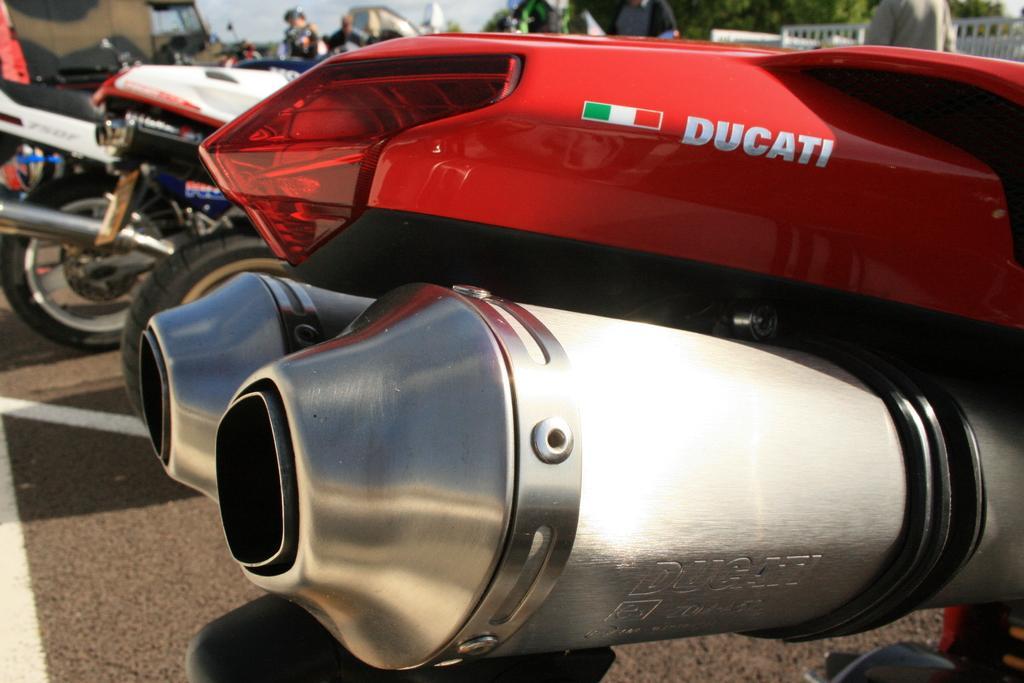Could you give a brief overview of what you see in this image? In this image in the foreground there is a vehicle, and in the background there are some vehicles and some persons trees and railing. At the bottom there is road. 